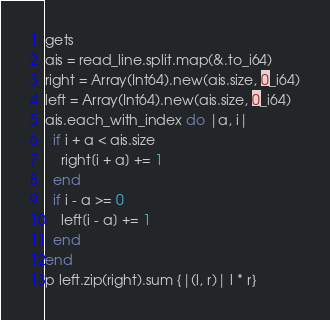<code> <loc_0><loc_0><loc_500><loc_500><_Crystal_>gets
ais = read_line.split.map(&.to_i64)
right = Array(Int64).new(ais.size, 0_i64)
left = Array(Int64).new(ais.size, 0_i64)
ais.each_with_index do |a, i|
  if i + a < ais.size
    right[i + a] += 1
  end
  if i - a >= 0
    left[i - a] += 1
  end
end
p left.zip(right).sum {|(l, r)| l * r}
</code> 